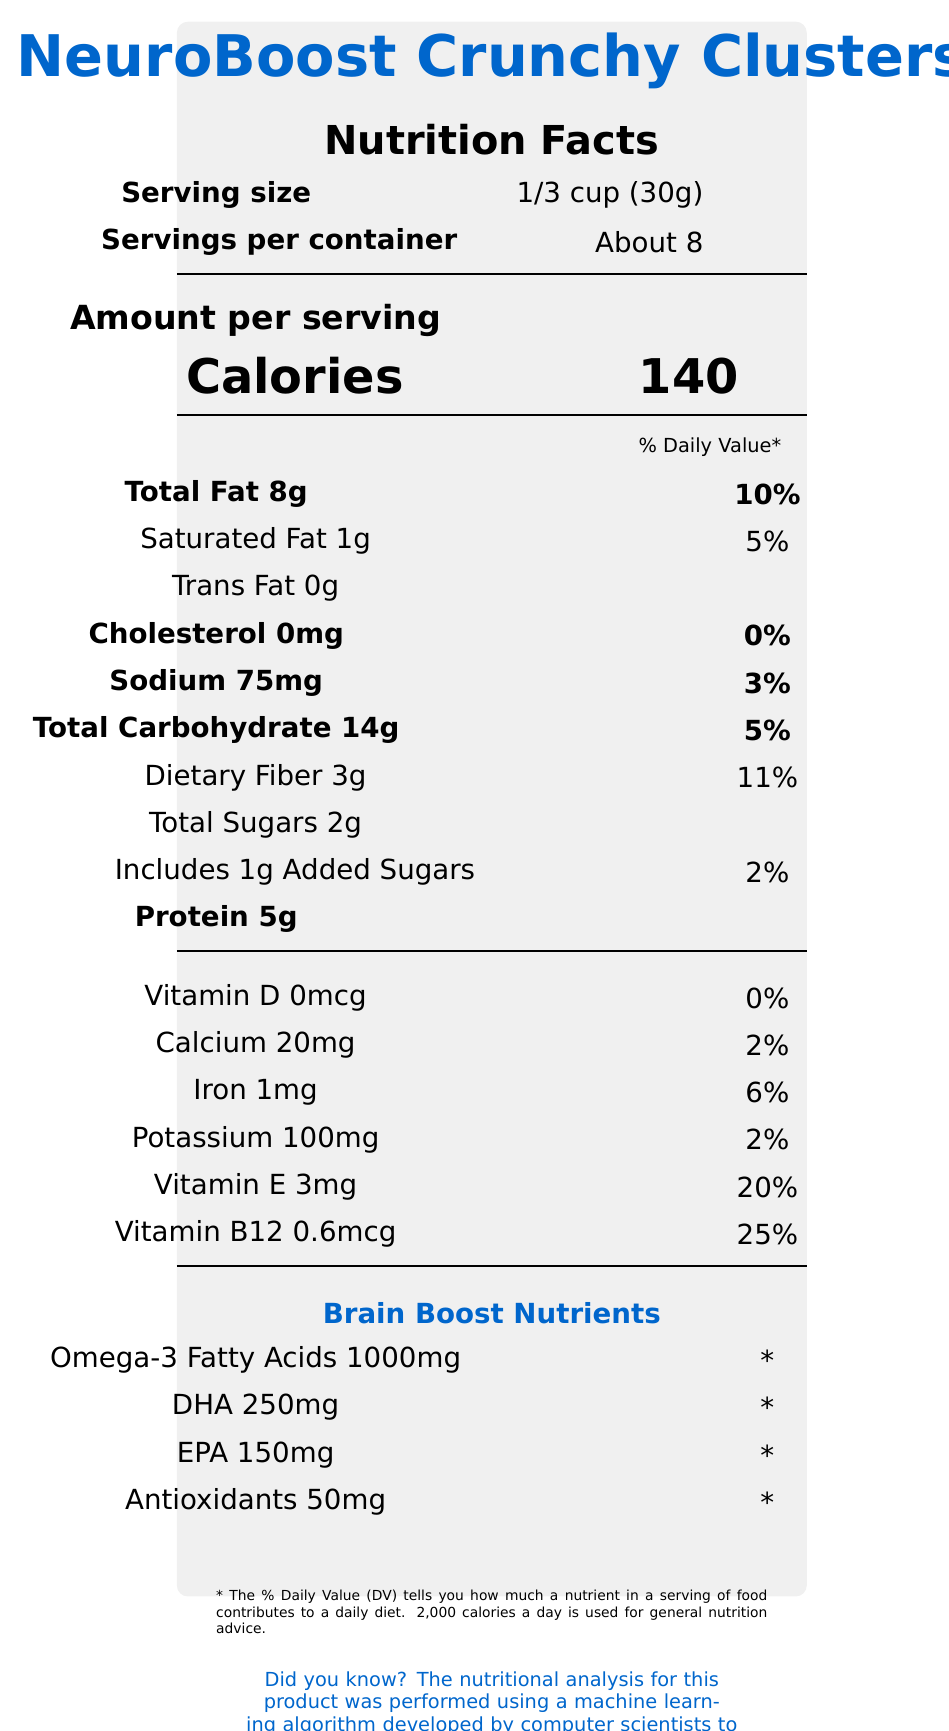what is the serving size of NeuroBoost Crunchy Clusters? The serving size is listed as "1/3 cup (30g)" at the top of the document.
Answer: 1/3 cup (30g) how many servings are in the container? The document mentions there are "About 8" servings per container.
Answer: About 8 what is the total fat content per serving? The total fat content is listed as "Total Fat 8g" under the nutritional information section.
Answer: 8g what percentage of the daily value of Vitamin B12 does each serving provide? The document states that each serving provides "Vitamin B12 0.6mcg" which is "25%" of the daily value.
Answer: 25% what ingredients are used in NeuroBoost Crunchy Clusters? The ingredients are listed in the ingredient section of the document.
Answer: Almonds, Walnuts, Pumpkin Seeds, Chia Seeds, Dried Blueberries, Algal Oil (Source of DHA and EPA), Brown Rice Syrup, Rosemary Extract (for freshness) How many grams of protein are in each serving? The amount of protein per serving is listed as "Protein 5g".
Answer: 5g Which of the following is the source of DHA and EPA in NeuroBoost Crunchy Clusters?
A. Fish Oil
B. Algal Oil
C. Flaxseed Oil
D. Olive Oil The document lists "Algal Oil (Source of DHA and EPA)" as one of the ingredients.
Answer: B How much dietary fiber does one serving contain?
A. 1g
B. 3g
C. 5g
D. 10g The dietary fiber per serving is listed as "Dietary Fiber 3g".
Answer: B Is there any trans fat in NeuroBoost Crunchy Clusters? The document lists "Trans Fat 0g" indicating there is no trans fat in the product.
Answer: No Is NeuroBoost Crunchy Clusters non-GMO? The claim "Non-GMO" appears under the claims section in the document.
Answer: Yes Provide a summary of the Nutrition Facts document for NeuroBoost Crunchy Clusters. The explanation details the layout and content of the document, covering all major sections such as nutrient amounts, ingredients, and special claims.
Answer: NeuroBoost Crunchy Clusters is a snack marketed as "brain food," rich in omega-3 fatty acids and antioxidants. Each 1/3 cup (30g) serving contains 140 calories, 8g total fat, 1g saturated fat, 0g trans fat, 75mg sodium, 14g total carbohydrates, 3g dietary fiber, 2g total sugars, 1g added sugars, and 5g protein. Key nutrients include Vitamin E, Vitamin B12, DHA, EPA, and antioxidants. The ingredients list includes nuts, seeds, dried blueberries, and algal oil. The product is non-GMO and free from artificial flavors or preservatives. What percentage of the daily value of calcium does each serving of the product provide? The calcium content per serving is listed as "Calcium 20mg" which is "2%" of the daily value.
Answer: 2% What type of extract is used for freshness in NeuroBoost Crunchy Clusters? The ingredient list mentions "Rosemary Extract (for freshness)".
Answer: Rosemary Extract What nutrient amounts are not provided with a % Daily Value? The brain boost nutrients (Omega-3 Fatty Acids 1000mg, DHA 250mg, EPA 150mg, Antioxidants 50mg) are listed with a '*' indicating the % Daily Value is not provided.
Answer: Omega-3 Fatty Acids, DHA, EPA, Antioxidants How many calories come from fat per serving of NeuroBoost Crunchy Clusters? The document does not provide specific information regarding calories from fat, only the total calorie count and fat content.
Answer: Not enough information 